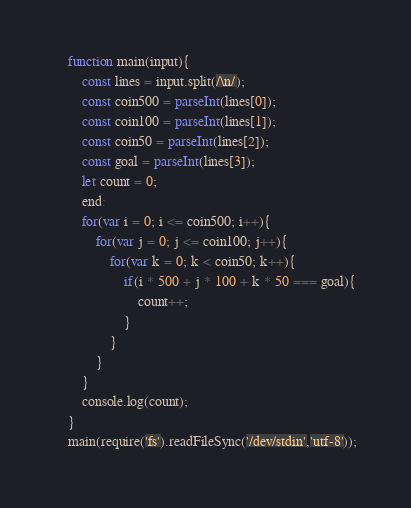<code> <loc_0><loc_0><loc_500><loc_500><_JavaScript_>    function main(input){
        const lines = input.split(/\n/);
        const coin500 = parseInt(lines[0]);
        const coin100 = parseInt(lines[1]);
        const coin50 = parseInt(lines[2]);
        const goal = parseInt(lines[3]);
        let count = 0;
        end:
        for(var i = 0; i <= coin500; i++){
            for(var j = 0; j <= coin100; j++){
                for(var k = 0; k < coin50; k++){
                    if(i * 500 + j * 100 + k * 50 === goal){
                        count++;
                    }
                }   
            }
        }
        console.log(count);
    }
    main(require('fs').readFileSync('/dev/stdin','utf-8'));</code> 